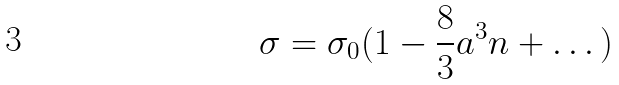<formula> <loc_0><loc_0><loc_500><loc_500>\sigma = \sigma _ { 0 } ( 1 - \frac { 8 } { 3 } a ^ { 3 } n + \dots )</formula> 